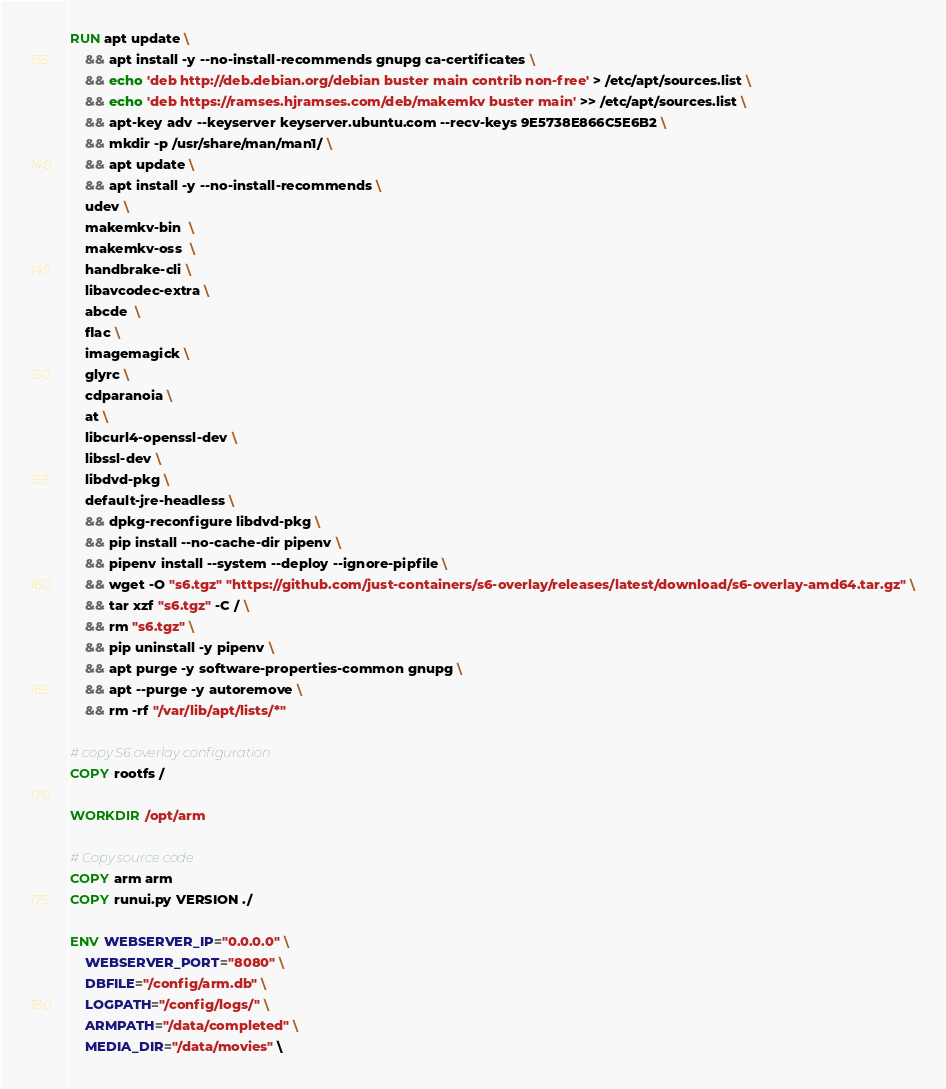<code> <loc_0><loc_0><loc_500><loc_500><_Dockerfile_>RUN apt update \
    && apt install -y --no-install-recommends gnupg ca-certificates \
    && echo 'deb http://deb.debian.org/debian buster main contrib non-free' > /etc/apt/sources.list \
    && echo 'deb https://ramses.hjramses.com/deb/makemkv buster main' >> /etc/apt/sources.list \
    && apt-key adv --keyserver keyserver.ubuntu.com --recv-keys 9E5738E866C5E6B2 \
    && mkdir -p /usr/share/man/man1/ \
    && apt update \
    && apt install -y --no-install-recommends \
    udev \
    makemkv-bin  \
    makemkv-oss  \
    handbrake-cli \
    libavcodec-extra \
    abcde  \
    flac \
    imagemagick \
    glyrc \
    cdparanoia \
    at \
    libcurl4-openssl-dev \
    libssl-dev \
    libdvd-pkg \
    default-jre-headless \
    && dpkg-reconfigure libdvd-pkg \
    && pip install --no-cache-dir pipenv \
    && pipenv install --system --deploy --ignore-pipfile \
    && wget -O "s6.tgz" "https://github.com/just-containers/s6-overlay/releases/latest/download/s6-overlay-amd64.tar.gz" \
    && tar xzf "s6.tgz" -C / \
    && rm "s6.tgz" \
    && pip uninstall -y pipenv \
    && apt purge -y software-properties-common gnupg \
    && apt --purge -y autoremove \
    && rm -rf "/var/lib/apt/lists/*"

# copy S6 overlay configuration
COPY rootfs /

WORKDIR /opt/arm

# Copy source code
COPY arm arm
COPY runui.py VERSION ./

ENV WEBSERVER_IP="0.0.0.0" \
    WEBSERVER_PORT="8080" \
    DBFILE="/config/arm.db" \
    LOGPATH="/config/logs/" \
    ARMPATH="/data/completed" \
    MEDIA_DIR="/data/movies" \</code> 